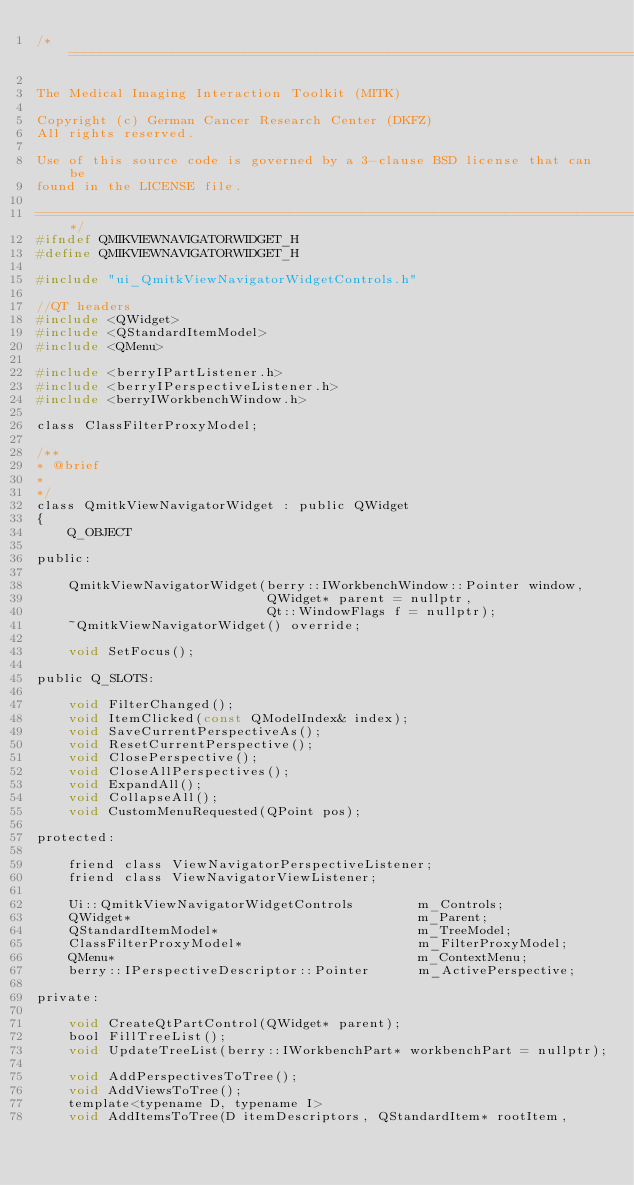Convert code to text. <code><loc_0><loc_0><loc_500><loc_500><_C_>/*============================================================================

The Medical Imaging Interaction Toolkit (MITK)

Copyright (c) German Cancer Research Center (DKFZ)
All rights reserved.

Use of this source code is governed by a 3-clause BSD license that can be
found in the LICENSE file.

============================================================================*/
#ifndef QMIKVIEWNAVIGATORWIDGET_H
#define QMIKVIEWNAVIGATORWIDGET_H

#include "ui_QmitkViewNavigatorWidgetControls.h"

//QT headers
#include <QWidget>
#include <QStandardItemModel>
#include <QMenu>

#include <berryIPartListener.h>
#include <berryIPerspectiveListener.h>
#include <berryIWorkbenchWindow.h>

class ClassFilterProxyModel;

/**
* @brief
*
*/
class QmitkViewNavigatorWidget : public QWidget
{
    Q_OBJECT

public:

    QmitkViewNavigatorWidget(berry::IWorkbenchWindow::Pointer window,
                             QWidget* parent = nullptr,
                             Qt::WindowFlags f = nullptr);
    ~QmitkViewNavigatorWidget() override;

    void SetFocus();

public Q_SLOTS:

    void FilterChanged();
    void ItemClicked(const QModelIndex& index);
    void SaveCurrentPerspectiveAs();
    void ResetCurrentPerspective();
    void ClosePerspective();
    void CloseAllPerspectives();
    void ExpandAll();
    void CollapseAll();
    void CustomMenuRequested(QPoint pos);

protected:

    friend class ViewNavigatorPerspectiveListener;
    friend class ViewNavigatorViewListener;

    Ui::QmitkViewNavigatorWidgetControls        m_Controls;
    QWidget*                                    m_Parent;
    QStandardItemModel*                         m_TreeModel;
    ClassFilterProxyModel*                      m_FilterProxyModel;
    QMenu*                                      m_ContextMenu;
    berry::IPerspectiveDescriptor::Pointer      m_ActivePerspective;

private:

    void CreateQtPartControl(QWidget* parent);
    bool FillTreeList();
    void UpdateTreeList(berry::IWorkbenchPart* workbenchPart = nullptr);

    void AddPerspectivesToTree();
    void AddViewsToTree();
    template<typename D, typename I>
    void AddItemsToTree(D itemDescriptors, QStandardItem* rootItem,</code> 